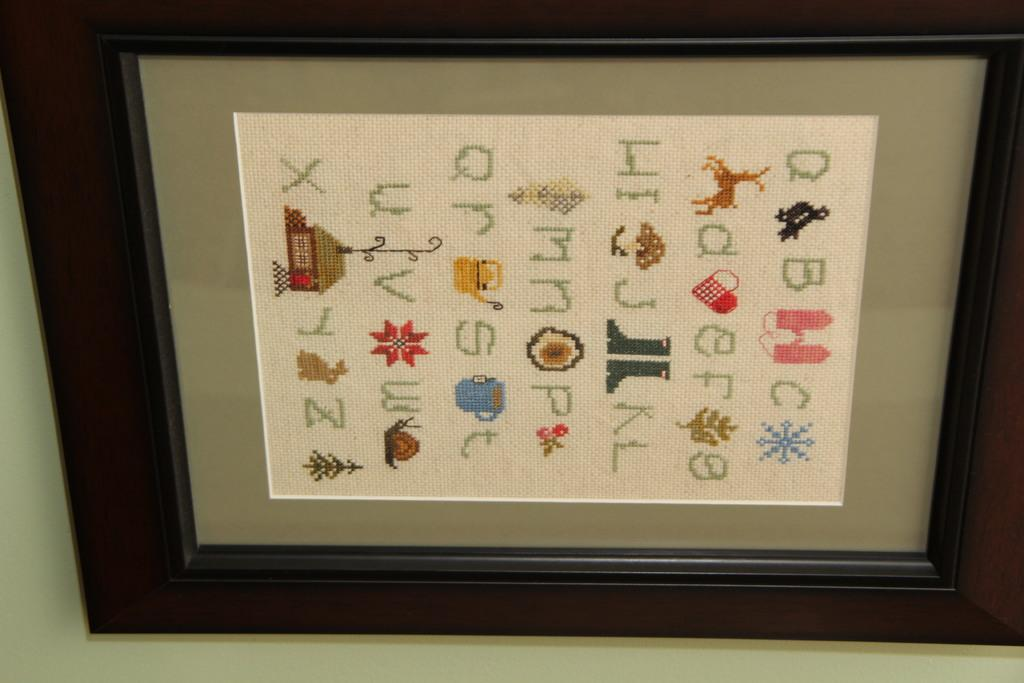<image>
Offer a succinct explanation of the picture presented. A framed needlepoint piece with upper and lower case letters of the alphabet, A to Z. 